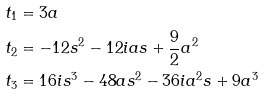<formula> <loc_0><loc_0><loc_500><loc_500>t _ { 1 } & = 3 a \\ t _ { 2 } & = - 1 2 s ^ { 2 } - 1 2 i a s + \frac { 9 } { 2 } a ^ { 2 } \\ t _ { 3 } & = 1 6 i s ^ { 3 } - 4 8 a s ^ { 2 } - 3 6 i a ^ { 2 } s + 9 a ^ { 3 }</formula> 